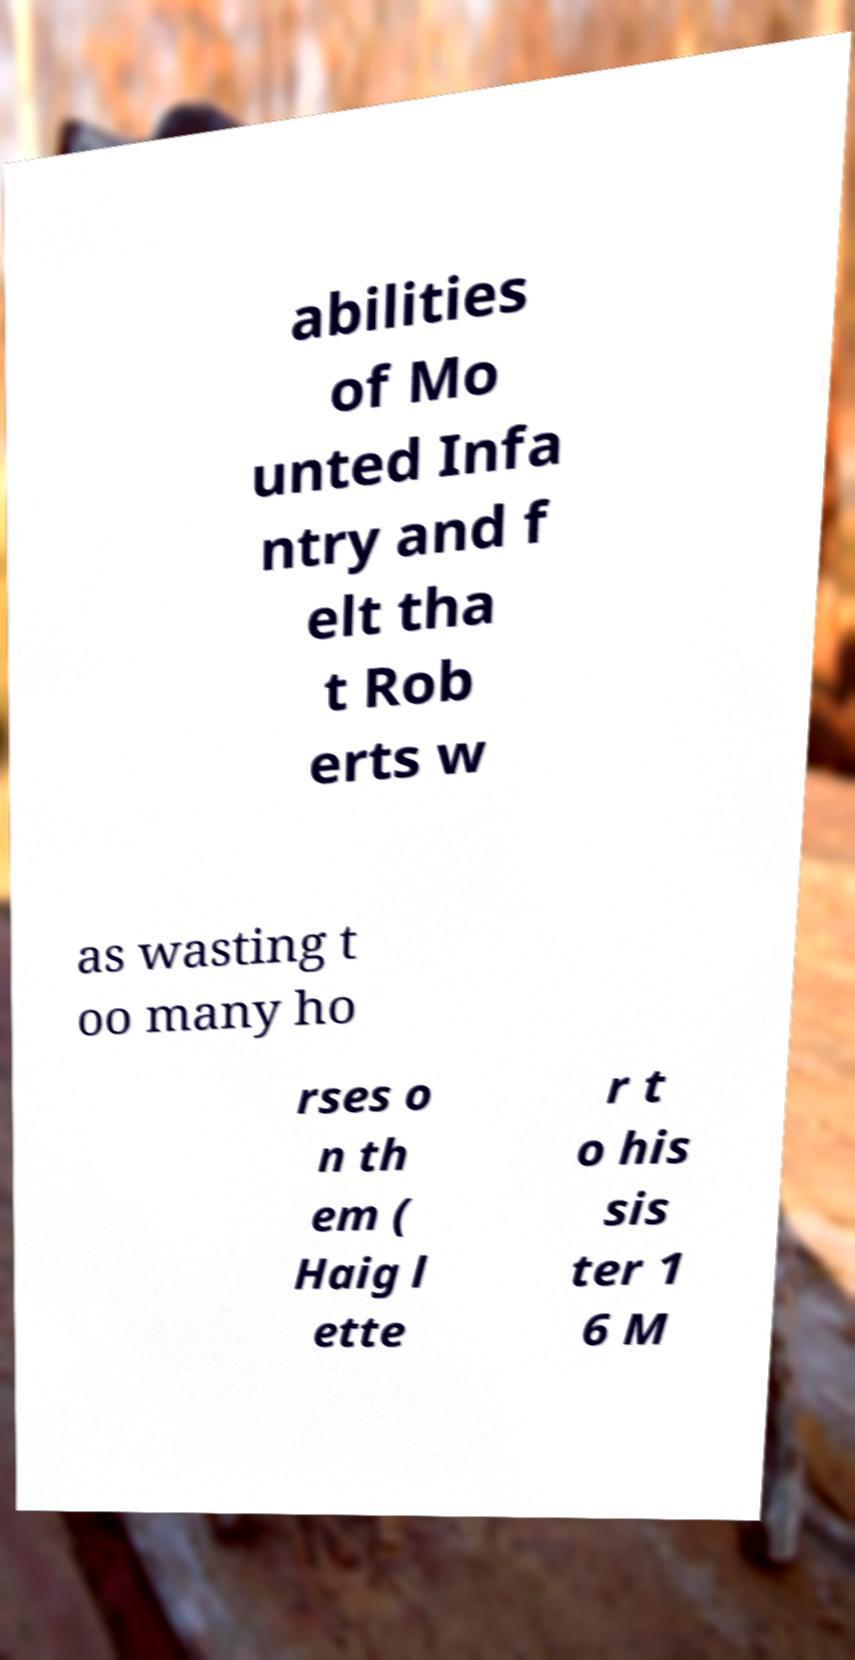Can you accurately transcribe the text from the provided image for me? abilities of Mo unted Infa ntry and f elt tha t Rob erts w as wasting t oo many ho rses o n th em ( Haig l ette r t o his sis ter 1 6 M 